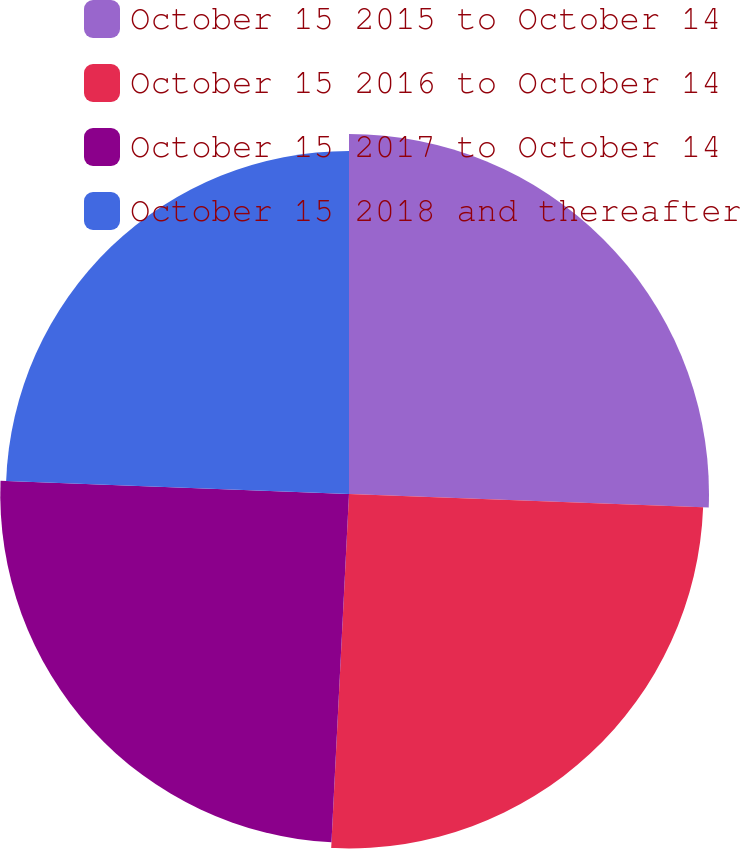Convert chart to OTSL. <chart><loc_0><loc_0><loc_500><loc_500><pie_chart><fcel>October 15 2015 to October 14<fcel>October 15 2016 to October 14<fcel>October 15 2017 to October 14<fcel>October 15 2018 and thereafter<nl><fcel>25.6%<fcel>25.2%<fcel>24.8%<fcel>24.4%<nl></chart> 